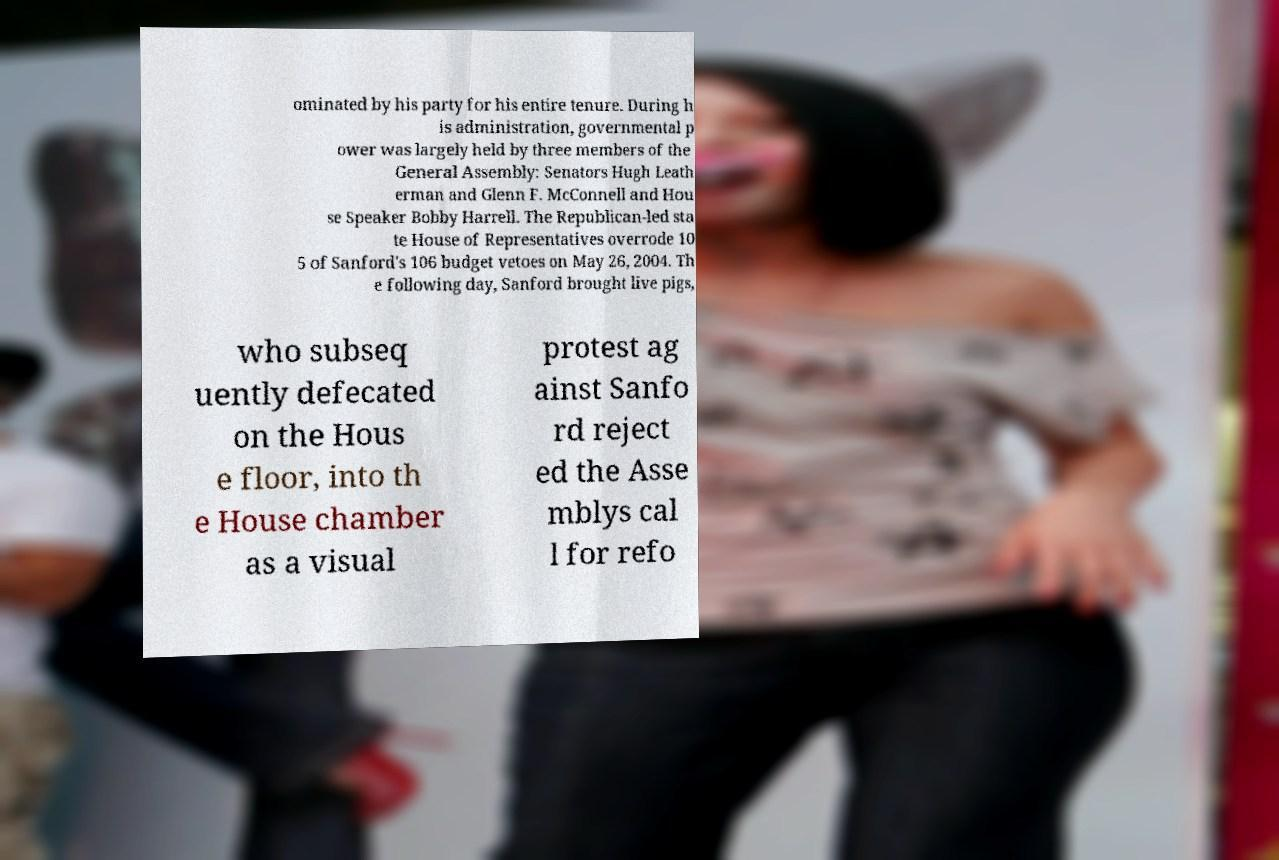I need the written content from this picture converted into text. Can you do that? ominated by his party for his entire tenure. During h is administration, governmental p ower was largely held by three members of the General Assembly: Senators Hugh Leath erman and Glenn F. McConnell and Hou se Speaker Bobby Harrell. The Republican-led sta te House of Representatives overrode 10 5 of Sanford's 106 budget vetoes on May 26, 2004. Th e following day, Sanford brought live pigs, who subseq uently defecated on the Hous e floor, into th e House chamber as a visual protest ag ainst Sanfo rd reject ed the Asse mblys cal l for refo 